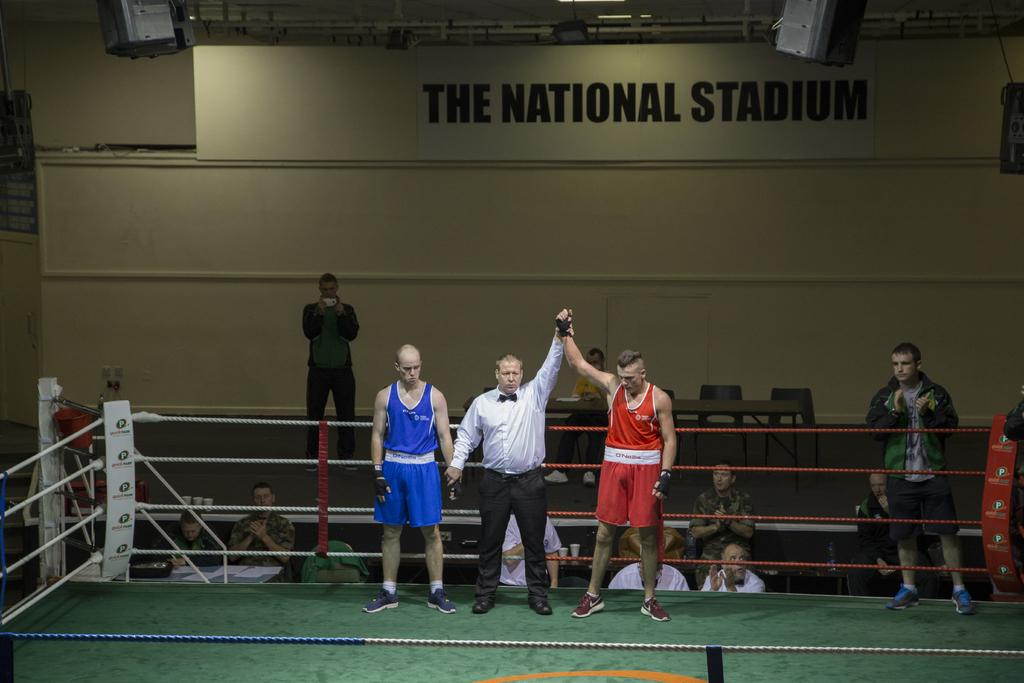<image>
Summarize the visual content of the image. a wrestling ring with a sign behind it that says 'the national stadium' 